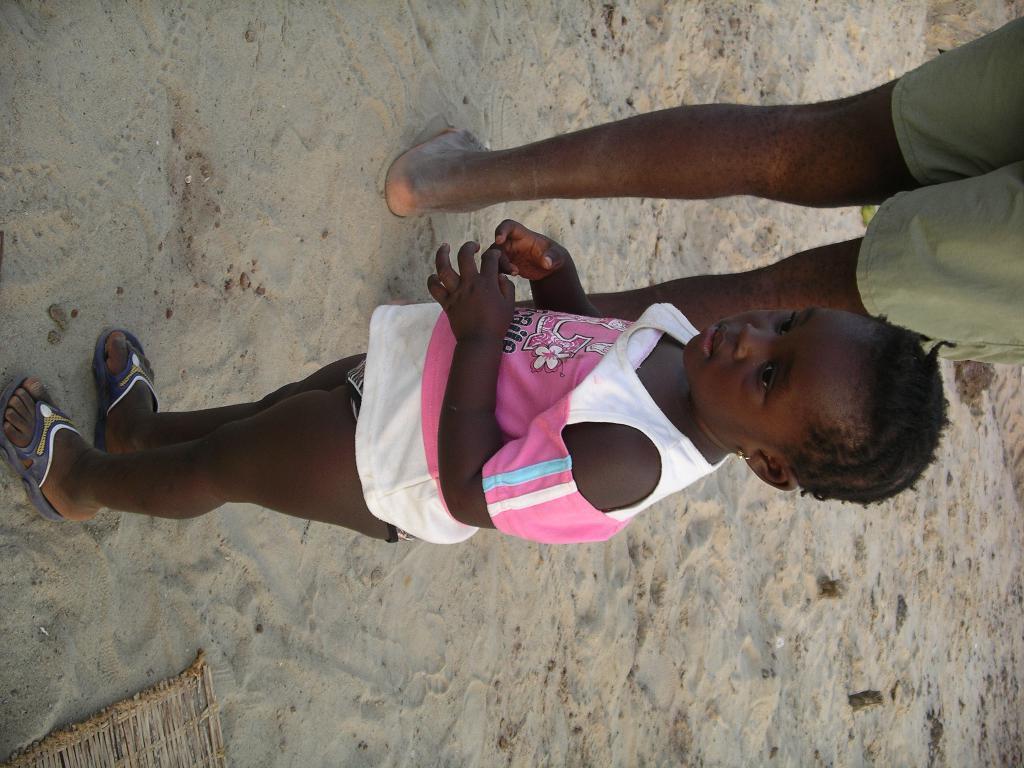How would you summarize this image in a sentence or two? There is a child wearing white and pink dress is standing on the sand. Also there is a person. 